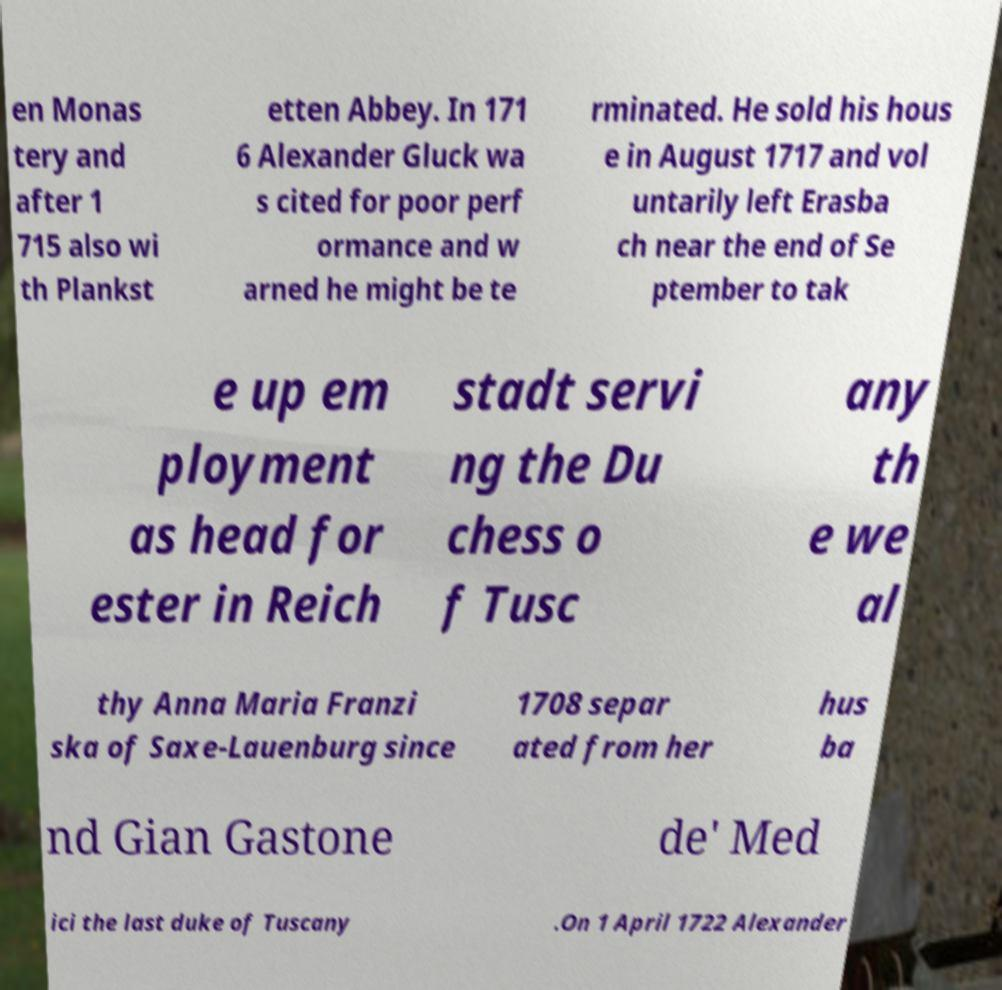For documentation purposes, I need the text within this image transcribed. Could you provide that? en Monas tery and after 1 715 also wi th Plankst etten Abbey. In 171 6 Alexander Gluck wa s cited for poor perf ormance and w arned he might be te rminated. He sold his hous e in August 1717 and vol untarily left Erasba ch near the end of Se ptember to tak e up em ployment as head for ester in Reich stadt servi ng the Du chess o f Tusc any th e we al thy Anna Maria Franzi ska of Saxe-Lauenburg since 1708 separ ated from her hus ba nd Gian Gastone de' Med ici the last duke of Tuscany .On 1 April 1722 Alexander 